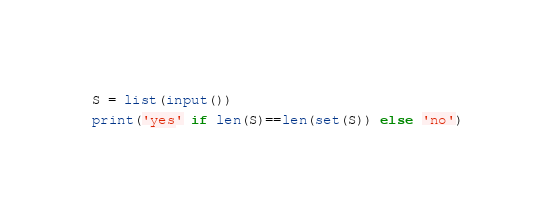<code> <loc_0><loc_0><loc_500><loc_500><_Python_>S = list(input())
print('yes' if len(S)==len(set(S)) else 'no')</code> 